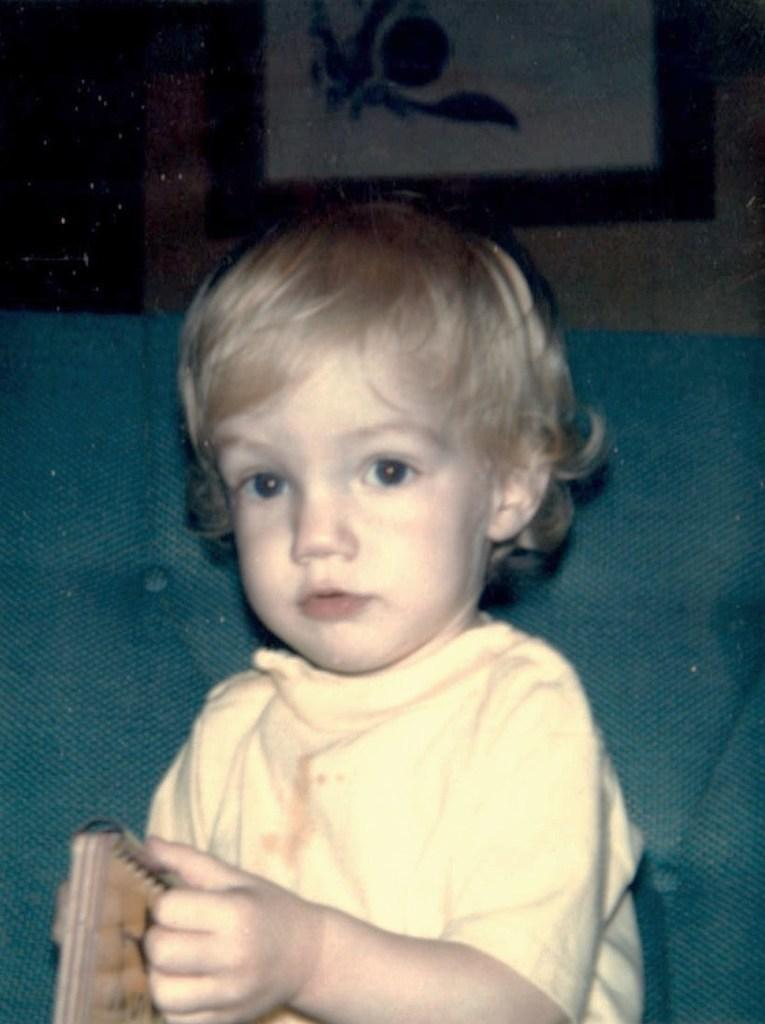What is the main subject of the image? The main subject of the image is a baby. What is the baby doing in the image? The baby is sitting in the image. What is the baby wearing in the image? The baby is wearing a yellow t-shirt in the image. How many toys are visible in the image? There are no toys visible in the image; it only features a baby sitting and wearing a yellow t-shirt. What is the price of the balloon in the image? There is no balloon present in the image, so it is not possible to determine its price. 